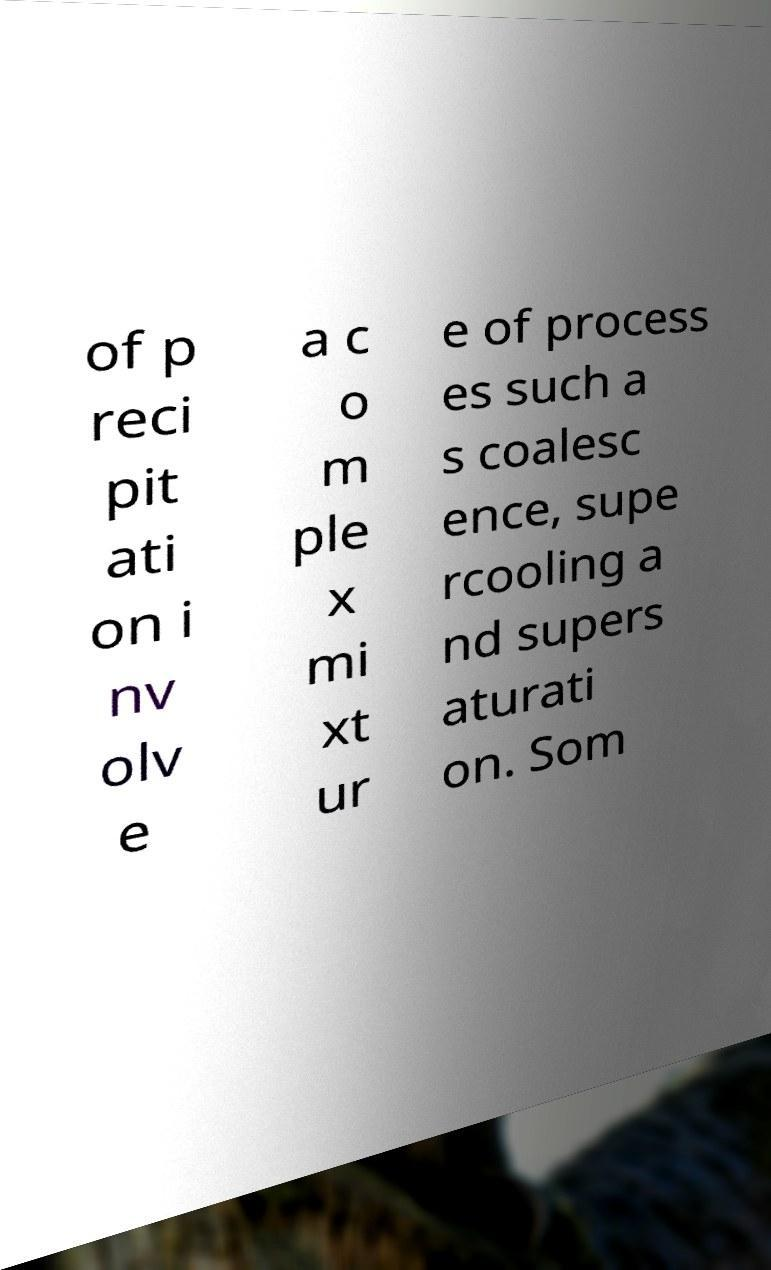Can you accurately transcribe the text from the provided image for me? of p reci pit ati on i nv olv e a c o m ple x mi xt ur e of process es such a s coalesc ence, supe rcooling a nd supers aturati on. Som 